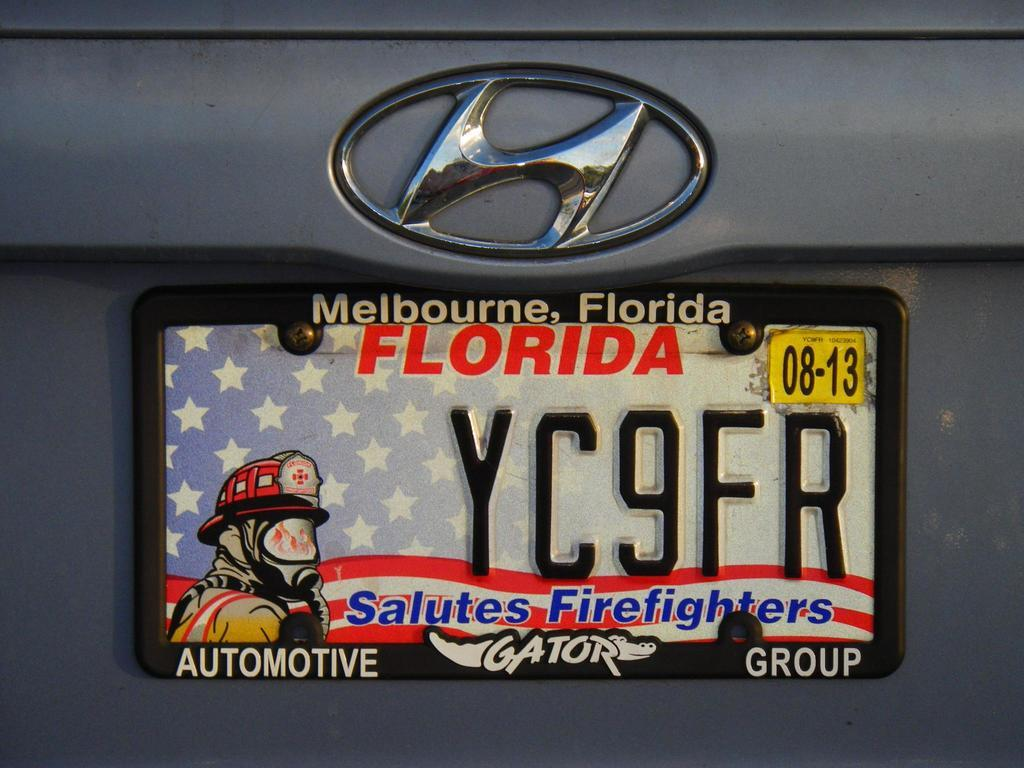<image>
Give a short and clear explanation of the subsequent image. A Florida license plate recognizes firefighters and includes an image of one. 